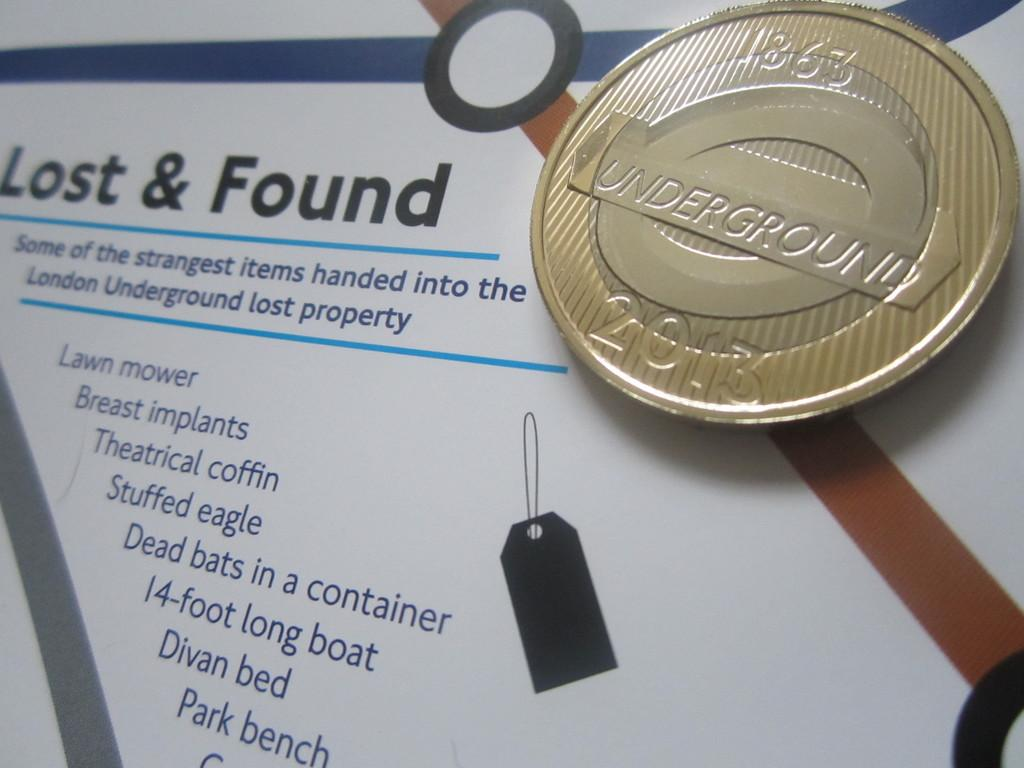<image>
Relay a brief, clear account of the picture shown. A lost and found poster with a London Underground coin 